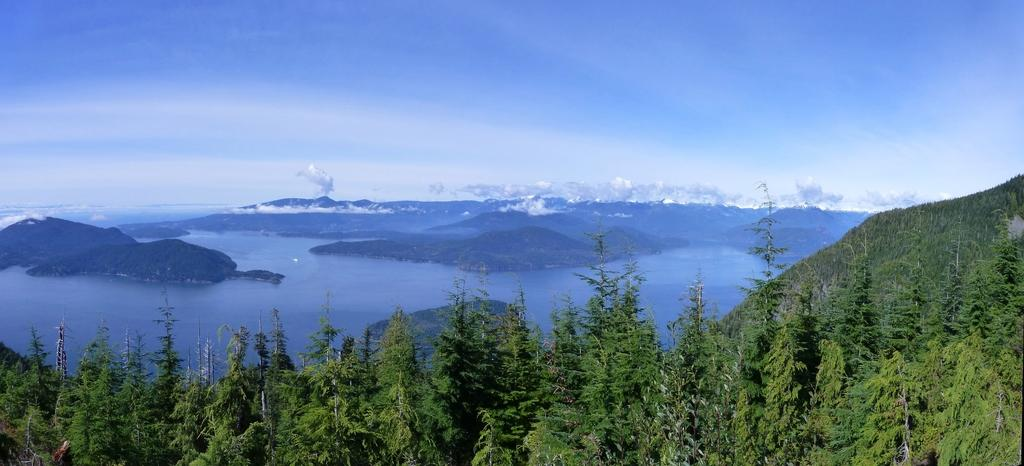What type of vegetation can be seen in the image? There are trees in the image. What natural element is visible in the image besides the trees? There is water visible in the image. What part of the sky is visible in the image? The sky is visible in the image. What time of day is it on the farm in the image? There is no farm present in the image, and therefore no specific time of day can be determined. What type of cloud can be seen in the image? There is no cloud visible in the image; only trees, water, and the sky are present. 